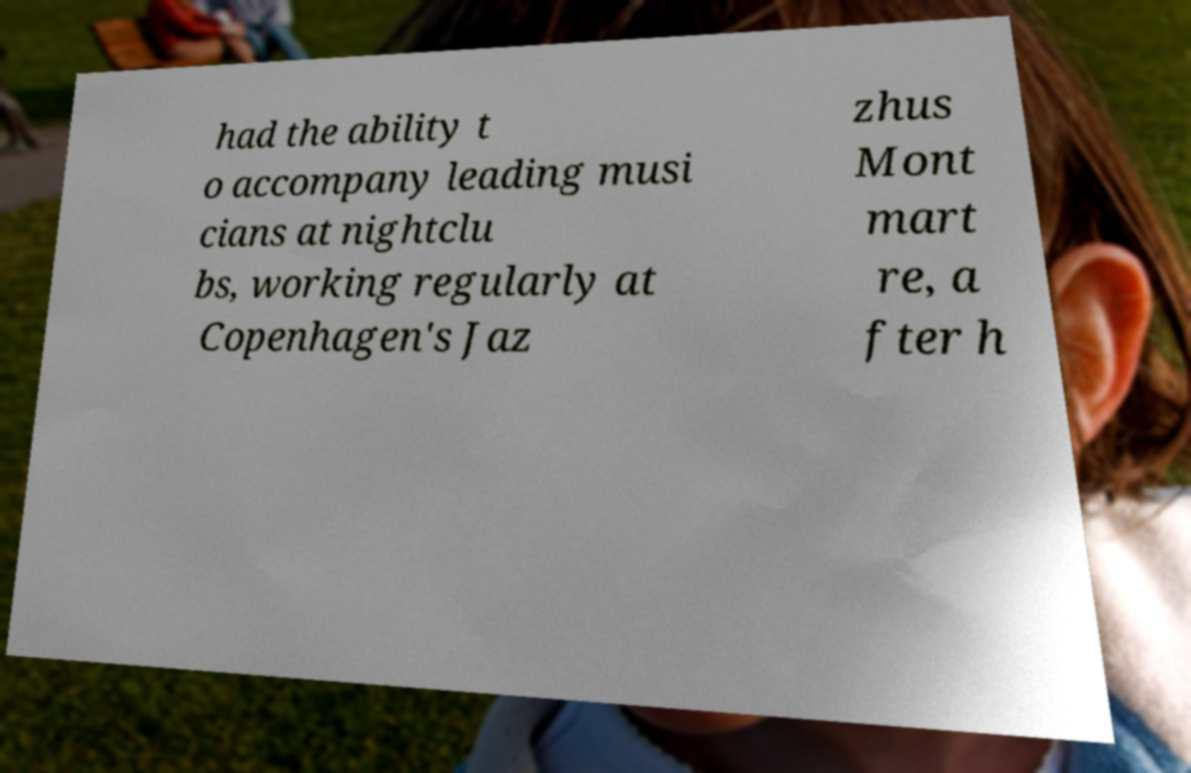What messages or text are displayed in this image? I need them in a readable, typed format. had the ability t o accompany leading musi cians at nightclu bs, working regularly at Copenhagen's Jaz zhus Mont mart re, a fter h 